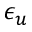Convert formula to latex. <formula><loc_0><loc_0><loc_500><loc_500>\epsilon _ { u }</formula> 